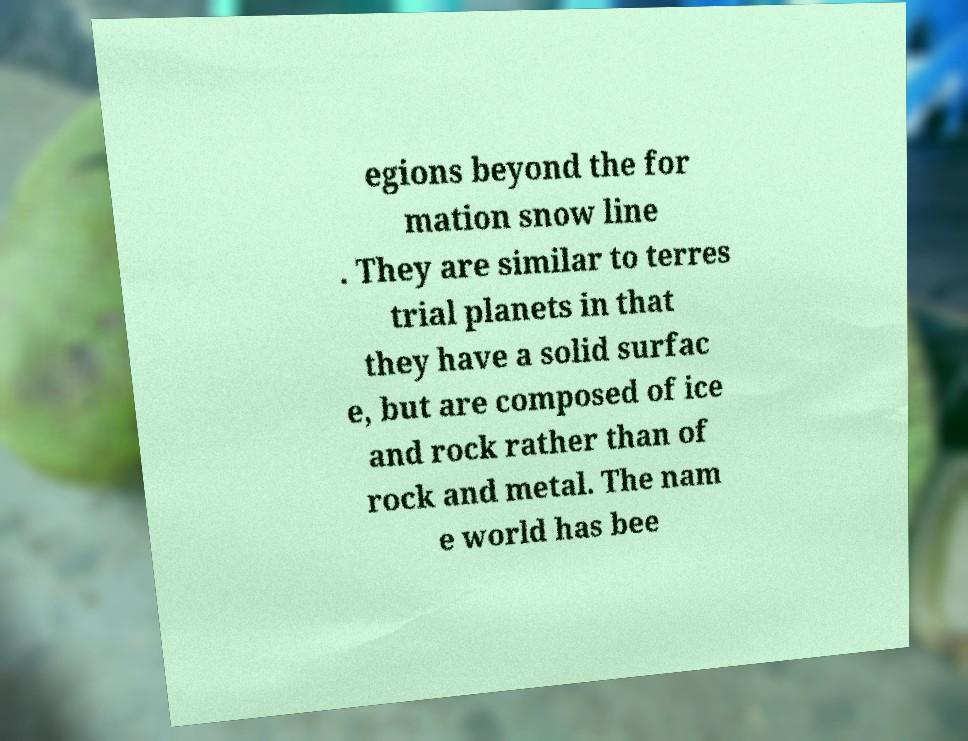For documentation purposes, I need the text within this image transcribed. Could you provide that? egions beyond the for mation snow line . They are similar to terres trial planets in that they have a solid surfac e, but are composed of ice and rock rather than of rock and metal. The nam e world has bee 